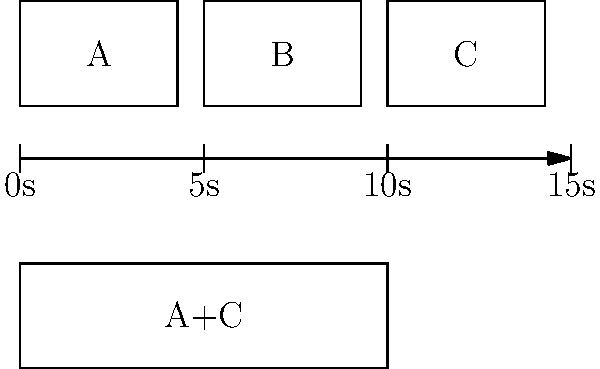In the storyboard above, three frames (A, B, and C) are shown with a 15-second timeline. The final edited sequence combines frames A and C into a 10-second clip. What percentage of the original timeline does the final edited sequence represent, and which frame has been omitted? To solve this question, let's follow these steps:

1. Analyze the storyboard:
   - There are three frames: A, B, and C
   - The timeline spans 15 seconds

2. Examine the final edited sequence:
   - It combines frames A and C
   - The new sequence is 10 seconds long

3. Calculate the percentage of the original timeline:
   - Original timeline: 15 seconds
   - Final edited sequence: 10 seconds
   - Percentage calculation: $(10 / 15) * 100 = 66.67\%$

4. Identify the omitted frame:
   - The final sequence contains A and C
   - Frame B is not included in the final edit

5. Interpret the results:
   - The final edited sequence represents 66.67% of the original timeline
   - Frame B has been omitted from the final edit

This question tests the film editing major's ability to interpret storyboards, understand timeline manipulation, and recognize the impact of frame selection on the final edited sequence.
Answer: 66.67%, Frame B 